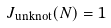Convert formula to latex. <formula><loc_0><loc_0><loc_500><loc_500>J _ { \text {unknot} } ( N ) = 1</formula> 